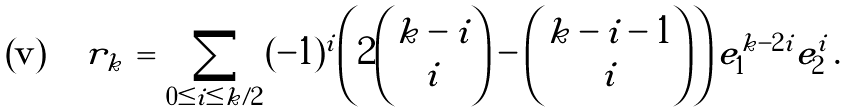Convert formula to latex. <formula><loc_0><loc_0><loc_500><loc_500>r _ { k } \, = \, \sum _ { 0 \leq i \leq k / 2 } ( - 1 ) ^ { i } \left ( 2 \binom { k - i } { i } - \binom { k - i - 1 } { i } \right ) e _ { 1 } ^ { k - 2 i } e _ { 2 } ^ { i } \, .</formula> 